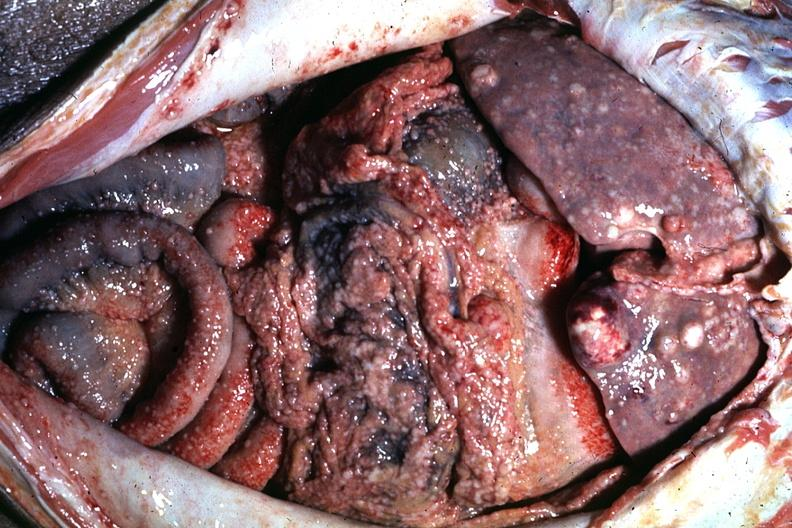what is present?
Answer the question using a single word or phrase. Peritoneum 